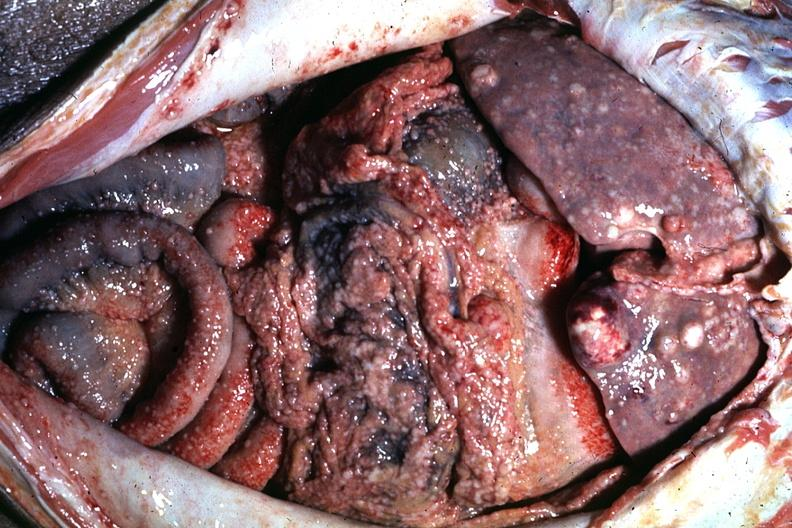what is present?
Answer the question using a single word or phrase. Peritoneum 